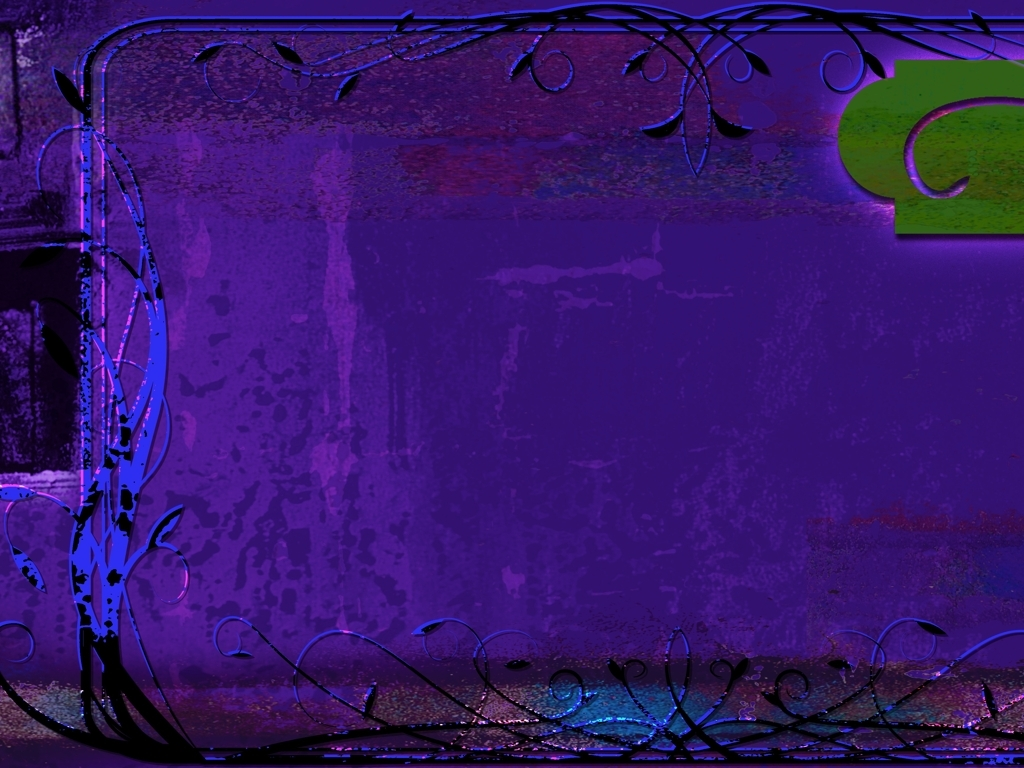How would you interpret the symbolic meaning of the shapes and structures within this image? The shapes and structures in the image, with their curving, organic lines and ambiguous forms, could symbolize the fluidity and interconnectedness of life and ideas. They might also represent growth, with plant-like structures suggesting a theme of natural development or evolution. The abstract nature allows for multiple interpretations, each viewer might find their meaning based on their perception. 